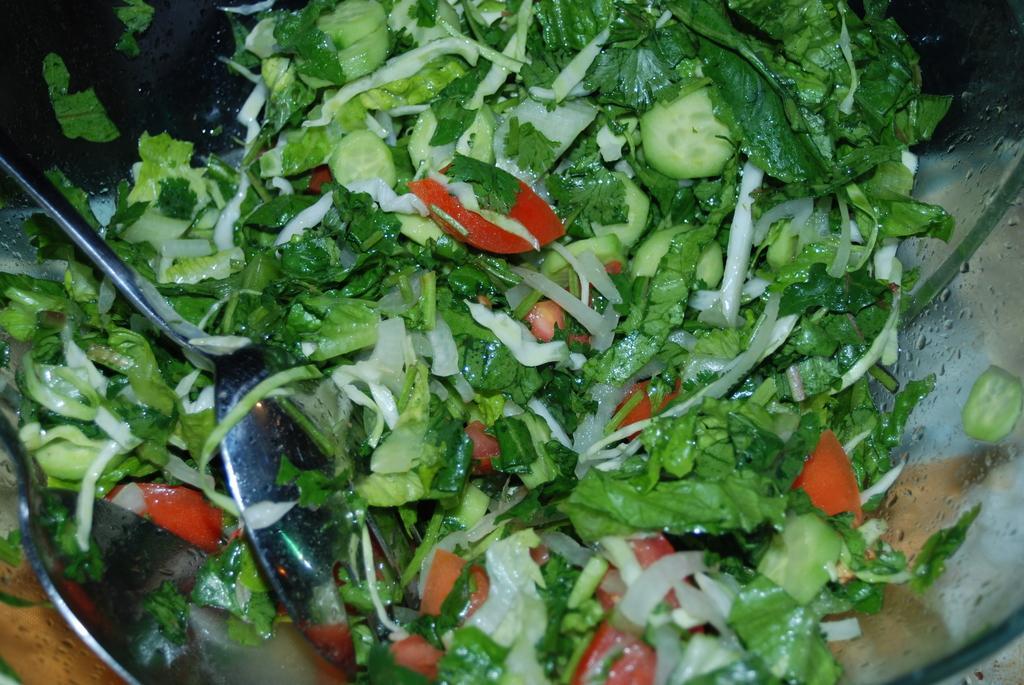Describe this image in one or two sentences. In this image there is a bowl truncated, there is food in the bowl, there are two spoons truncated towards the left of the image. 